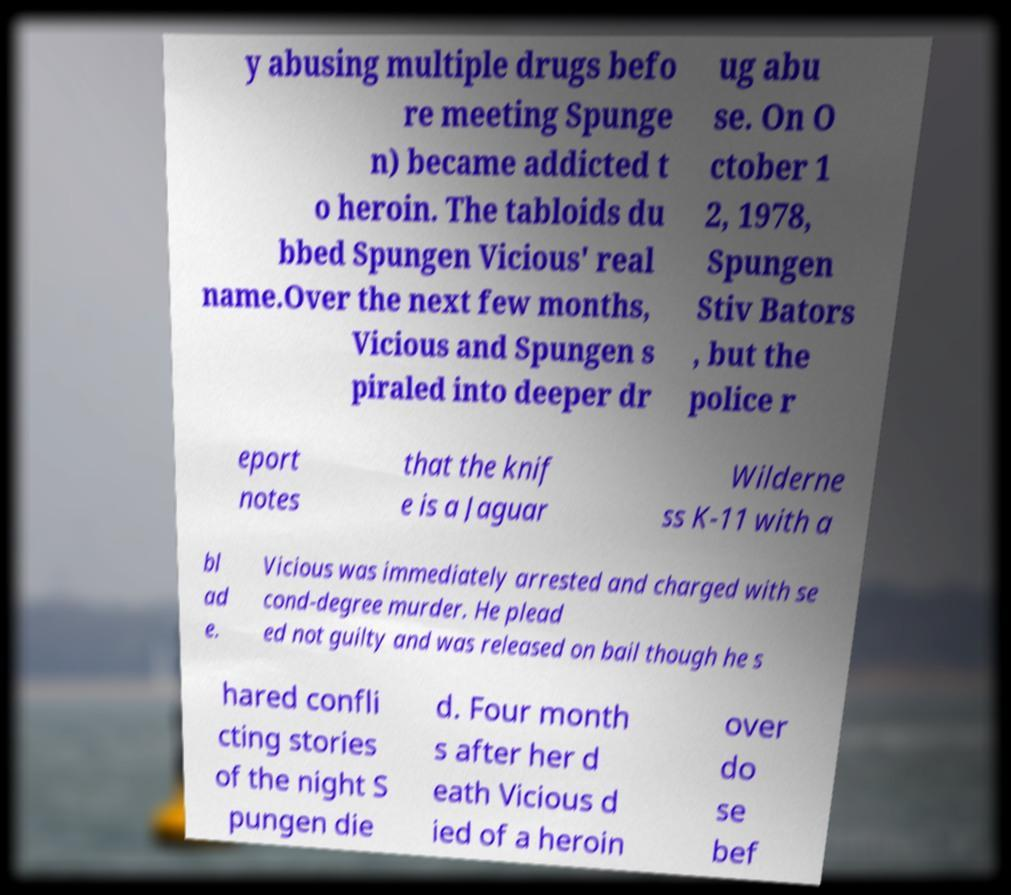Can you read and provide the text displayed in the image?This photo seems to have some interesting text. Can you extract and type it out for me? y abusing multiple drugs befo re meeting Spunge n) became addicted t o heroin. The tabloids du bbed Spungen Vicious' real name.Over the next few months, Vicious and Spungen s piraled into deeper dr ug abu se. On O ctober 1 2, 1978, Spungen Stiv Bators , but the police r eport notes that the knif e is a Jaguar Wilderne ss K-11 with a bl ad e. Vicious was immediately arrested and charged with se cond-degree murder. He plead ed not guilty and was released on bail though he s hared confli cting stories of the night S pungen die d. Four month s after her d eath Vicious d ied of a heroin over do se bef 